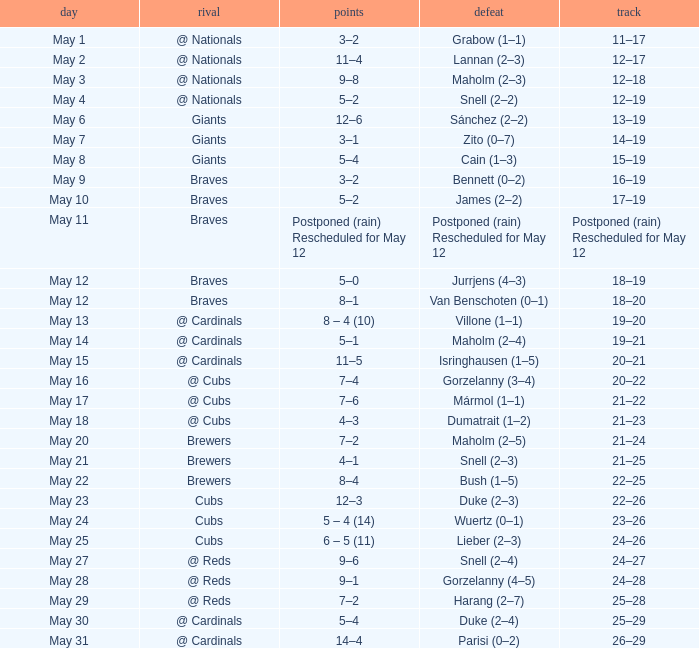What was the record of the game with a score of 12–6? 13–19. 